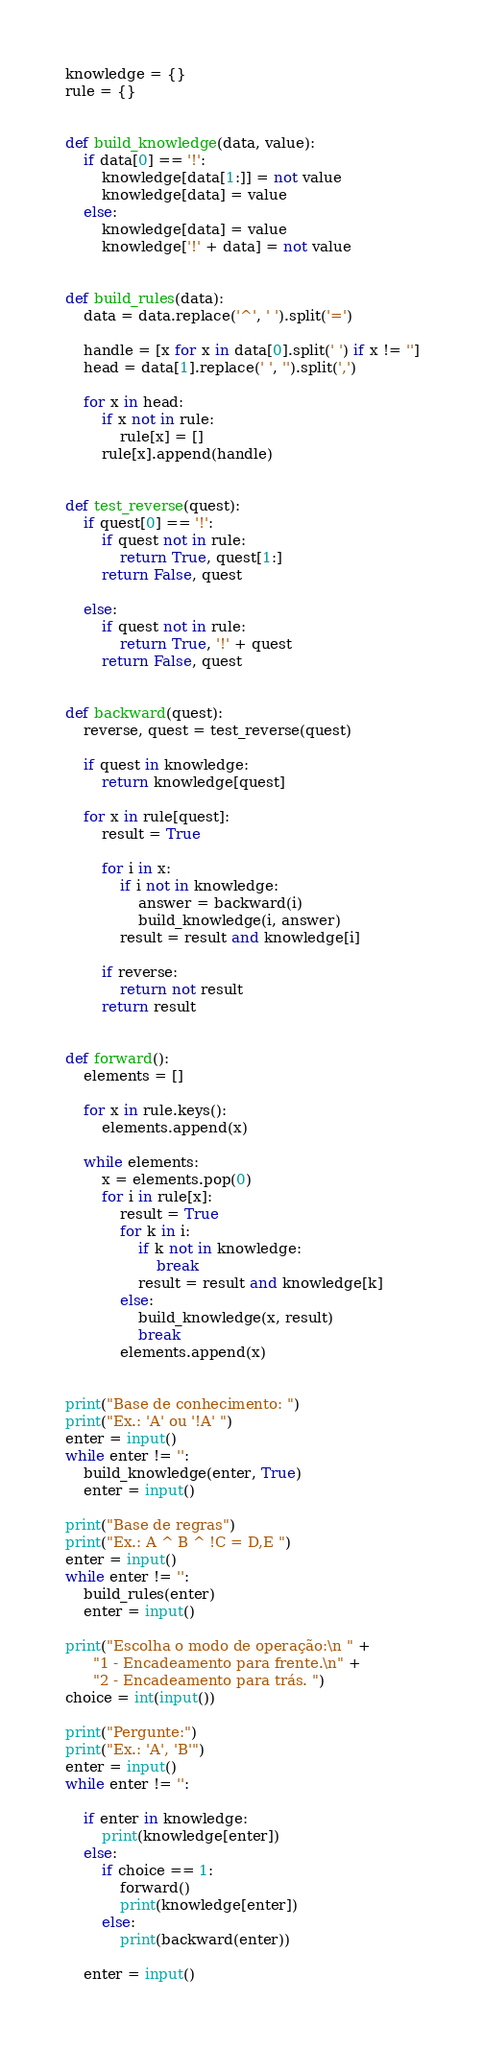<code> <loc_0><loc_0><loc_500><loc_500><_Python_>knowledge = {}
rule = {}


def build_knowledge(data, value):
    if data[0] == '!':
        knowledge[data[1:]] = not value
        knowledge[data] = value
    else:
        knowledge[data] = value
        knowledge['!' + data] = not value


def build_rules(data):
    data = data.replace('^', ' ').split('=')

    handle = [x for x in data[0].split(' ') if x != '']
    head = data[1].replace(' ', '').split(',')

    for x in head:
        if x not in rule:
            rule[x] = []
        rule[x].append(handle)


def test_reverse(quest):
    if quest[0] == '!':
        if quest not in rule:
            return True, quest[1:]
        return False, quest

    else:
        if quest not in rule:
            return True, '!' + quest
        return False, quest


def backward(quest):
    reverse, quest = test_reverse(quest)

    if quest in knowledge:
        return knowledge[quest]

    for x in rule[quest]:
        result = True

        for i in x:
            if i not in knowledge:
                answer = backward(i)
                build_knowledge(i, answer)
            result = result and knowledge[i]

        if reverse:
            return not result
        return result


def forward():
    elements = []

    for x in rule.keys():
        elements.append(x)

    while elements:
        x = elements.pop(0)
        for i in rule[x]:
            result = True
            for k in i:
                if k not in knowledge:
                    break
                result = result and knowledge[k]
            else:
                build_knowledge(x, result)
                break
            elements.append(x)


print("Base de conhecimento: ")
print("Ex.: 'A' ou '!A' ")
enter = input()
while enter != '':
    build_knowledge(enter, True)
    enter = input()

print("Base de regras")
print("Ex.: A ^ B ^ !C = D,E ")
enter = input()
while enter != '':
    build_rules(enter)
    enter = input()

print("Escolha o modo de operação:\n " +
      "1 - Encadeamento para frente.\n" +
      "2 - Encadeamento para trás. ")
choice = int(input())

print("Pergunte:")
print("Ex.: 'A', 'B'")
enter = input()
while enter != '':

    if enter in knowledge:
        print(knowledge[enter])
    else:
        if choice == 1:
            forward()
            print(knowledge[enter])
        else:
            print(backward(enter))

    enter = input()
</code> 